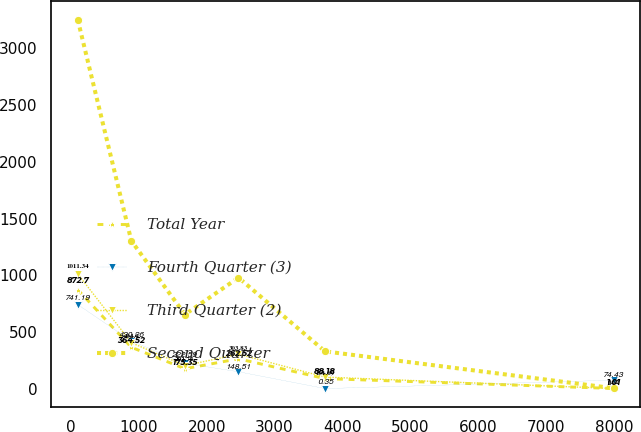Convert chart. <chart><loc_0><loc_0><loc_500><loc_500><line_chart><ecel><fcel>Total Year<fcel>Fourth Quarter (3)<fcel>Third Quarter (2)<fcel>Second Quarter<nl><fcel>100.59<fcel>872.7<fcel>741.19<fcel>1011.34<fcel>3254.07<nl><fcel>889.89<fcel>364.52<fcel>420.26<fcel>404.9<fcel>1303.51<nl><fcel>1679.19<fcel>175.35<fcel>222.59<fcel>202.76<fcel>653.33<nl><fcel>2468.49<fcel>262.52<fcel>148.51<fcel>303.83<fcel>978.42<nl><fcel>3743.43<fcel>88.18<fcel>0.35<fcel>101.69<fcel>328.24<nl><fcel>7993.6<fcel>1.01<fcel>74.43<fcel>0.62<fcel>3.15<nl></chart> 